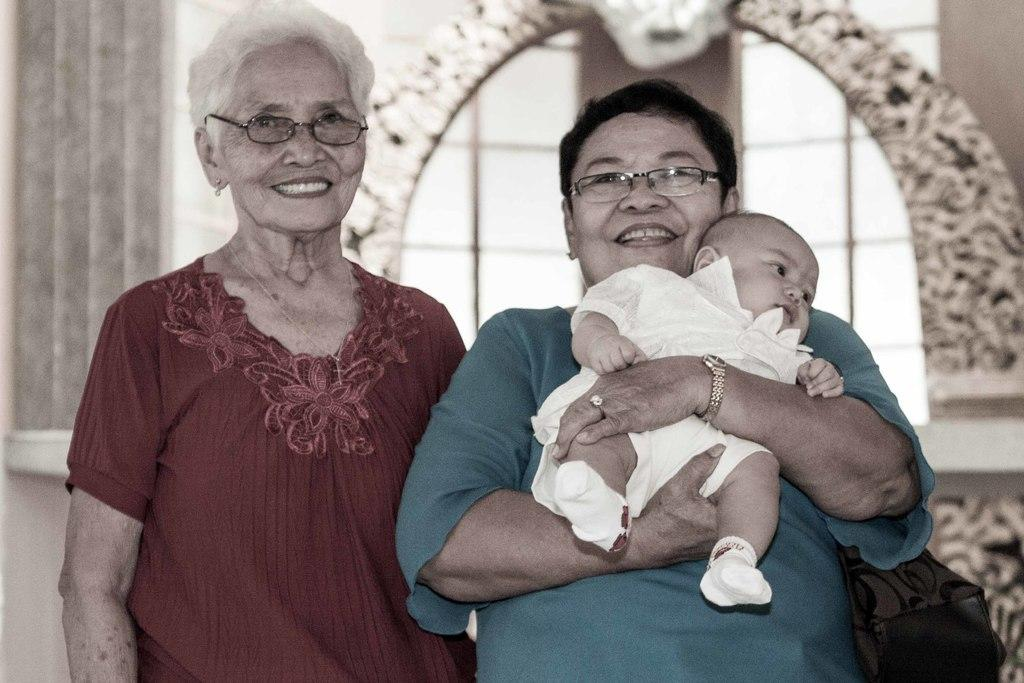How many people are in the image? There are three people in the image. What are the people in the image doing? Two persons are standing and smiling, while another person is carrying a baby. Can you describe the background of the image? The background of the image is blurred. What type of industry is being represented in the image? There is no specific industry represented in the image; it shows people standing, smiling, and carrying a baby. 